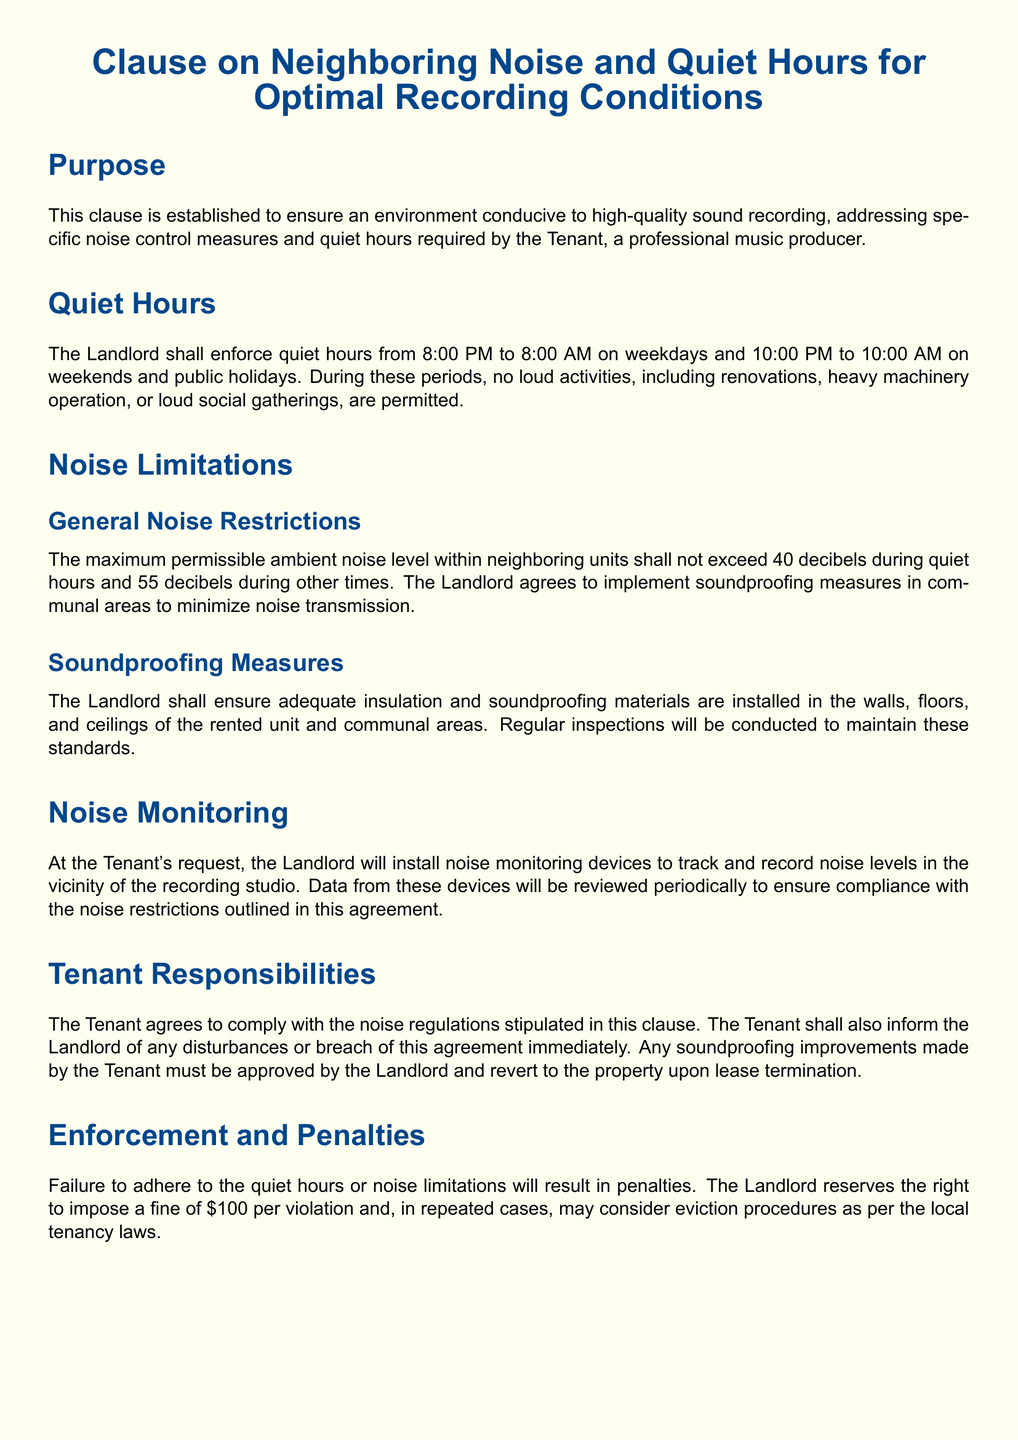What are quiet hours on weekdays? The quiet hours on weekdays are specified as the time period during which noise restrictions apply, which is from 8:00 PM to 8:00 AM.
Answer: 8:00 PM to 8:00 AM What is the maximum noise level allowed during quiet hours? The document specifies the maximum permissible ambient noise level during quiet hours, which should not exceed 40 decibels.
Answer: 40 decibels What penalties are mentioned for violating quiet hours? The penalties outlined include a fine per violation, specifically a monetary amount included in the lease agreement.
Answer: $100 Who is responsible for installing noise monitoring devices? The responsibility for installing noise monitoring devices is attributed to the Landlord, as mentioned in the noise monitoring section.
Answer: Landlord What happens to soundproofing improvements upon lease termination? The document states that any soundproofing improvements made by the Tenant must revert to the property when the lease is terminated.
Answer: Revert to the property What should a Tenant do if they experience noise disturbances? It is indicated that the Tenant agrees to inform the Landlord immediately about any disturbances or breaches of the noise agreement.
Answer: Inform the Landlord What is the purpose of this clause? The purpose is highlighted as being essential for a conducive environment for high-quality sound recording, particularly for the Tenant.
Answer: High-quality sound recording What is the effective range of quiet hours on weekends? The weekend quiet hours are specified as a different time period than weekdays, extending from 10:00 PM to 10:00 AM.
Answer: 10:00 PM to 10:00 AM 